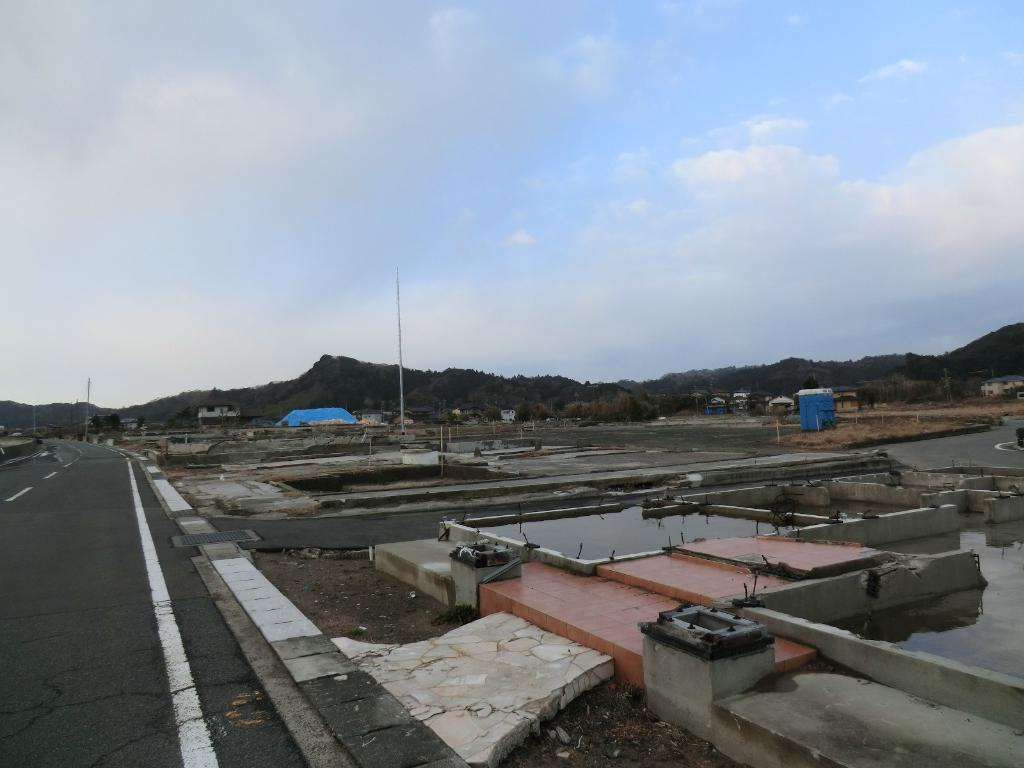What type of natural landscape can be seen in the image? There are hills in the image. What type of vegetation is present in the image? There are trees in the image. What type of man-made structures can be seen in the image? There are buildings in the image. What type of infrastructure is present in the image? There are poles and construction basements in the image. What type of transportation route is visible in the image? There is a road in the image. What is visible in the sky at the top of the image? There are clouds in the sky at the top of the image. What type of canvas is visible in the image? There is no canvas present in the image. How does the light change throughout the day in the image? The image is static and does not depict changes in light throughout the day. 